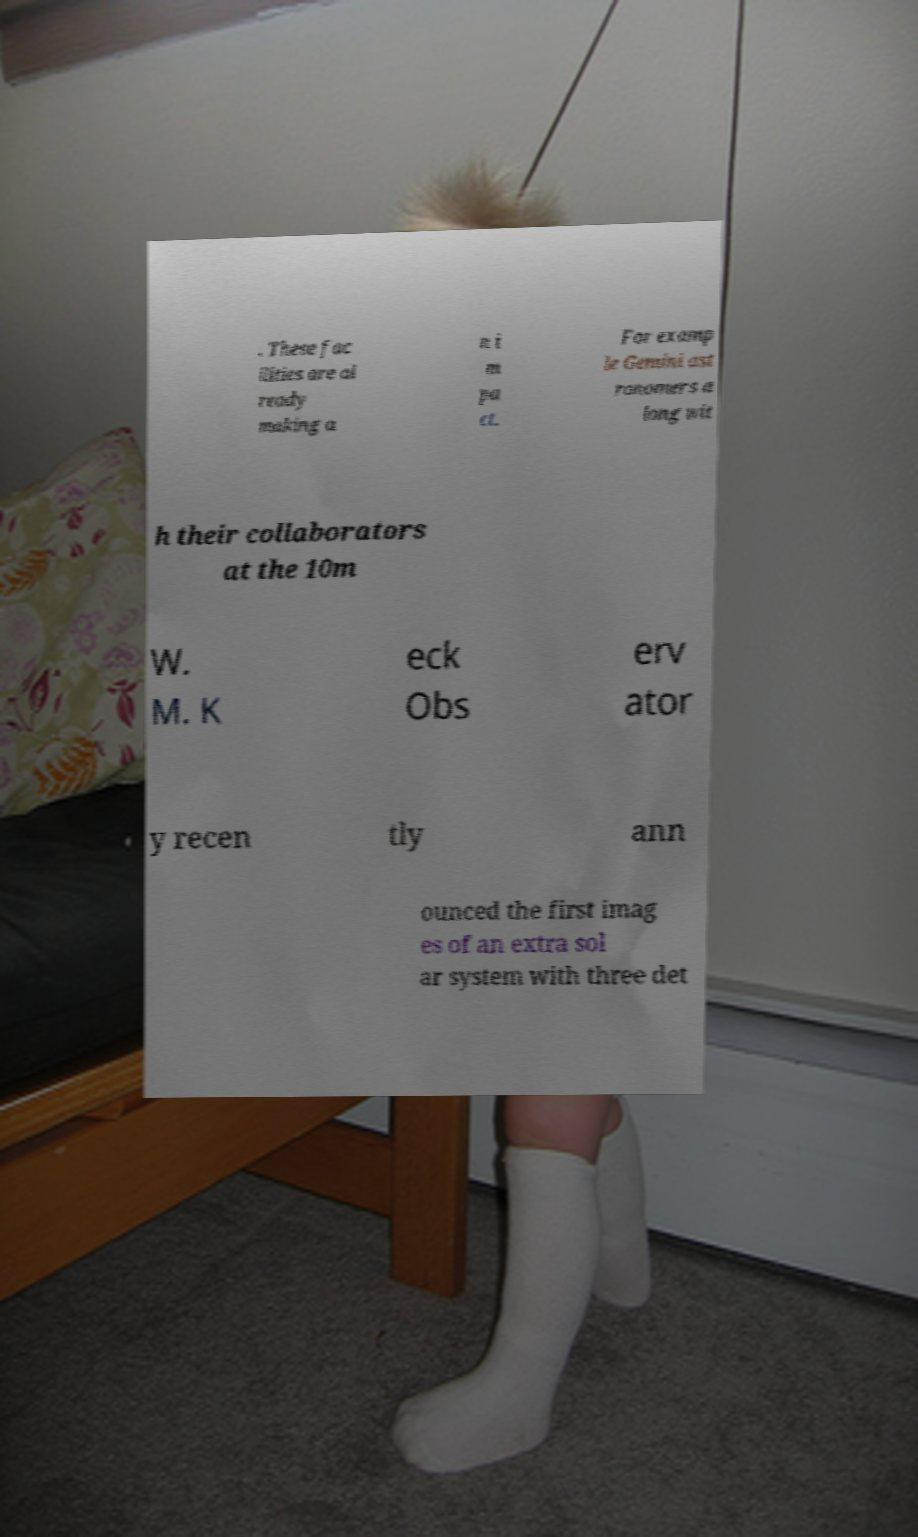Can you read and provide the text displayed in the image?This photo seems to have some interesting text. Can you extract and type it out for me? . These fac ilities are al ready making a n i m pa ct. For examp le Gemini ast ronomers a long wit h their collaborators at the 10m W. M. K eck Obs erv ator y recen tly ann ounced the first imag es of an extra sol ar system with three det 